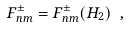<formula> <loc_0><loc_0><loc_500><loc_500>F ^ { \pm } _ { n m } = F ^ { \pm } _ { n m } ( H _ { 2 } ) \ ,</formula> 